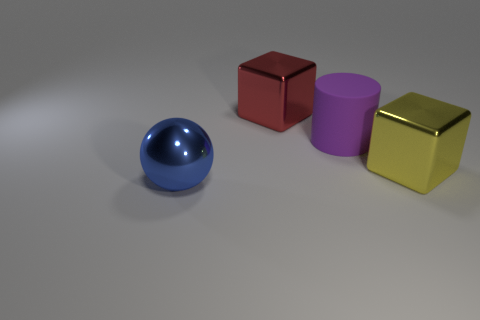Add 3 matte cylinders. How many objects exist? 7 Subtract all green spheres. Subtract all green cubes. How many spheres are left? 1 Subtract all cylinders. How many objects are left? 3 Add 1 purple things. How many purple things are left? 2 Add 1 small red rubber things. How many small red rubber things exist? 1 Subtract 0 green spheres. How many objects are left? 4 Subtract all large blue balls. Subtract all big purple metallic cubes. How many objects are left? 3 